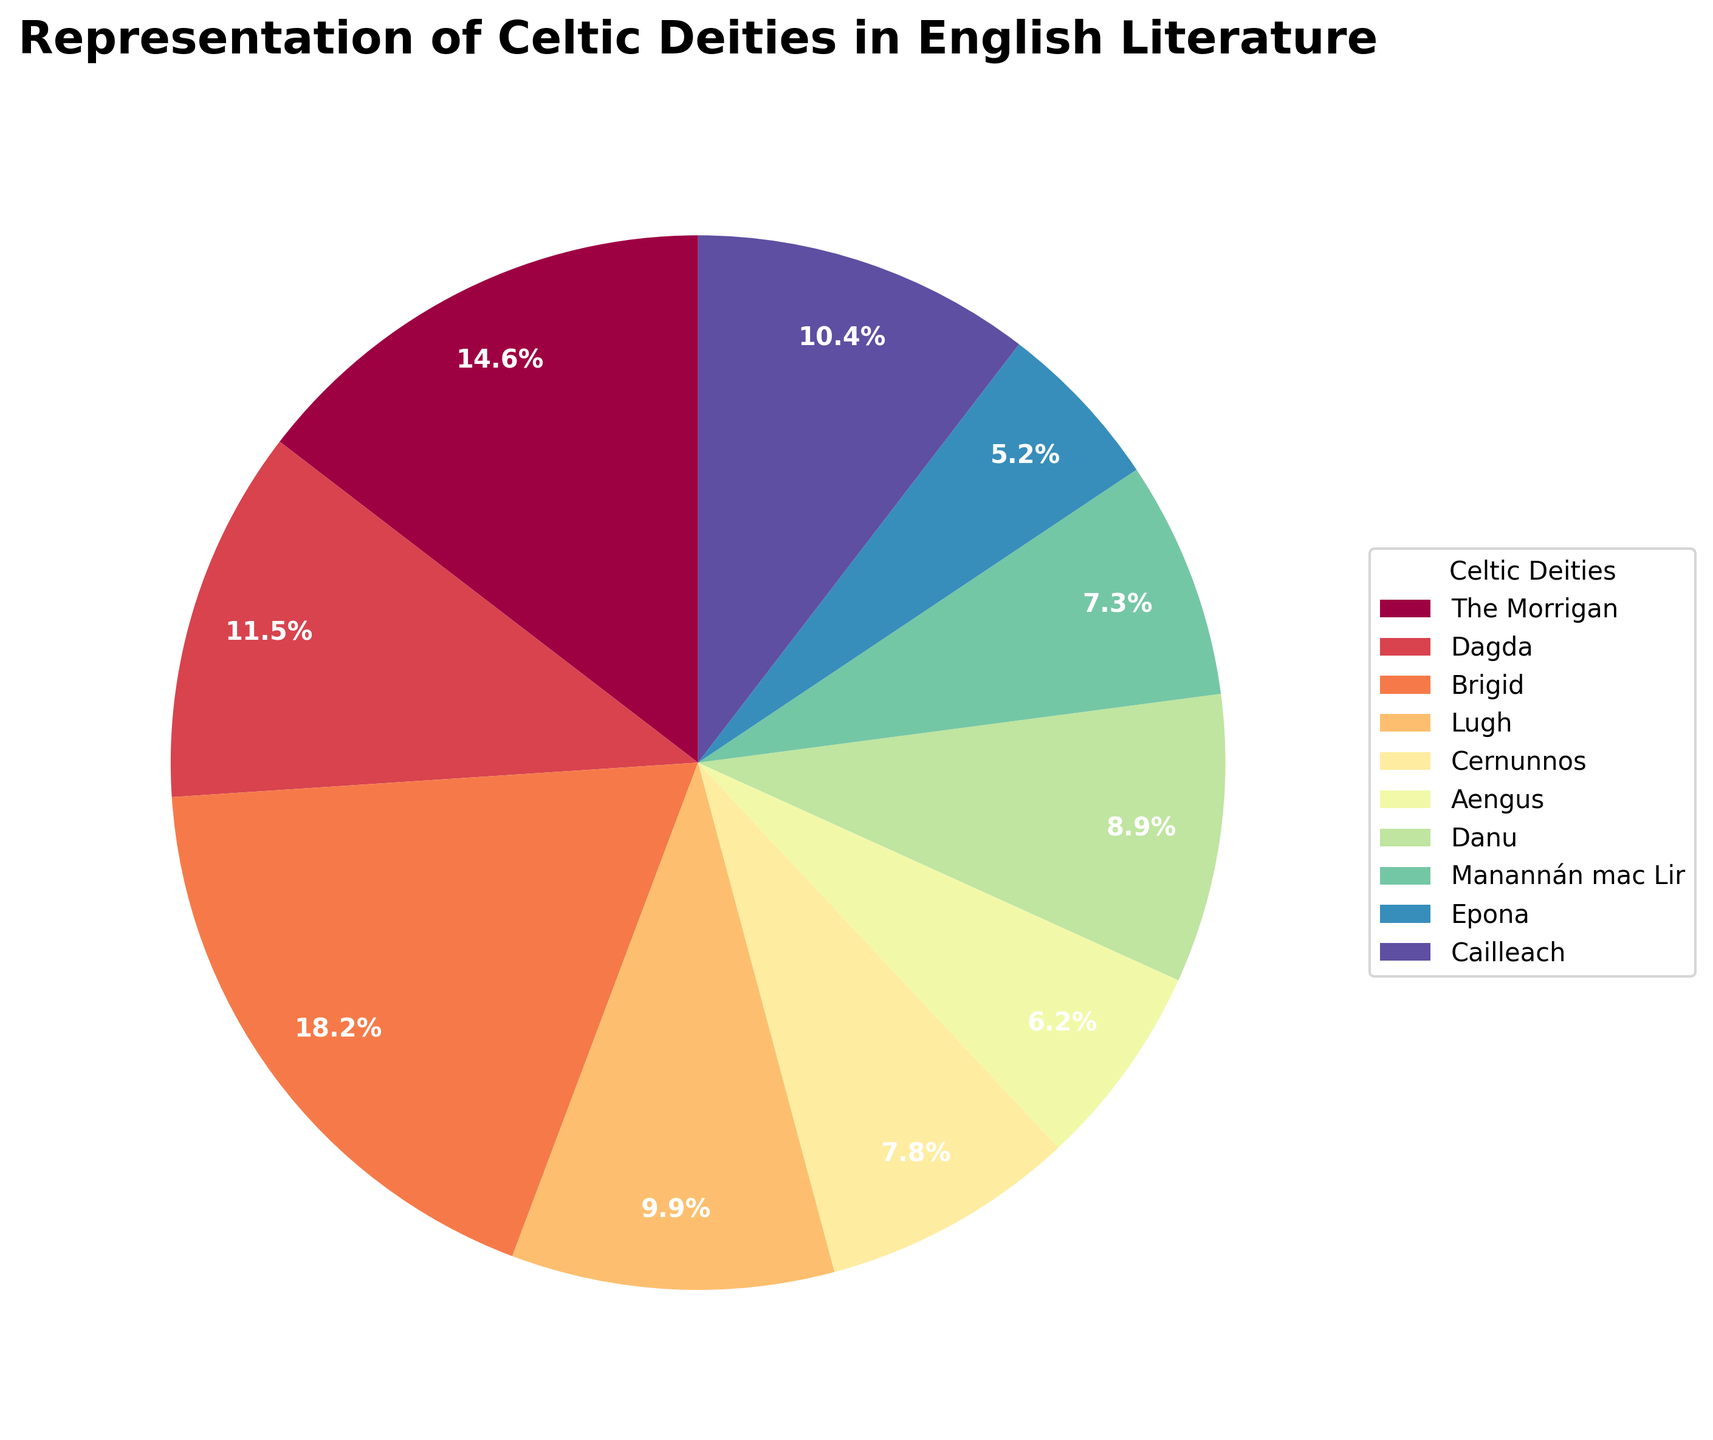Which Celtic deity is most frequently represented in English literature? By looking at the figure, we can see that Brigid has the largest section of the pie chart.
Answer: Brigid Which two deities have the least representation in English literature, and what are their total occurrences? Epona and Aengus have the smallest sections of the pie chart. Their occurrences are 10 and 12 respectively, so the total is 10 + 12.
Answer: 22 What is the difference in occurrences between The Morrigan and Cernunnos? By observing the pie chart, The Morrigan has 28 occurrences, and Cernunnos has 15. The difference is 28 - 15.
Answer: 13 Which Celtic deity has more occurrences: Lugh or Danu? The pie chart shows that Lugh has 19 occurrences and Danu has 17 occurrences.
Answer: Lugh What percentage of the total does The Morrigan represent? The pie chart shows that The Morrigan represents a percentage of the total, which is shown in the chart as one of the labels.
Answer: 16.4% What is the combined percentage of occurrences for Dagda and Cailleach? Dagda represents 12.9% and Cailleach represents 11.8% according to the pie chart. Their combined percentage is 12.9% + 11.8%.
Answer: 24.7% Which deity has a representation twice as large as Aengus? By inspecting the pie chart, Brigid represents 35 occurrences, while Aengus has 12 occurrences, which is almost three times Aengus’s occurrences. The closest is Cailleach, who has 20 occurrences, which is roughly twice that of Aengus’s occurrences.
Answer: Cailleach How do the occurrences of Manannán mac Lir compare to Epona? According to the pie chart, Manannán mac Lir has 14 occurrences, while Epona has 10.
Answer: Manannán mac Lir has more Which deities have occurrences that are greater than 10 but less than 20? The pie chart shows that Lugh (19), Danu (17), Manannán mac Lir (14), and Cernunnos (15) fall within this range.
Answer: Lugh, Danu, Manannán mac Lir, Cernunnos What's the average number of occurrences for all the deities combined? To find the average, sum all occurrences and divide by the number of deities. The occurrences are (28 + 22 + 35 + 19 + 15 + 12 + 17 + 14 + 10 + 20) = 192. There are 10 deities, so the average is 192 / 10.
Answer: 19.2 